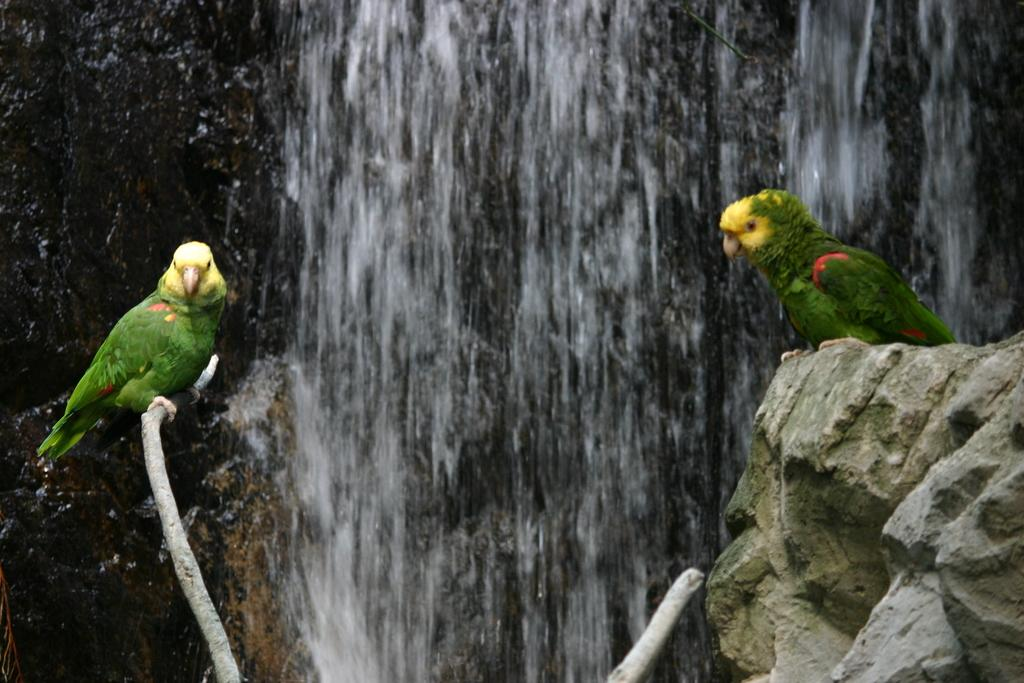How many birds are present in the image? There are two birds in the image. What else can be seen in the image besides the birds? There is a rock in the image. What is visible in the background of the image? There is a waterfall in the background of the image. What type of drug is the bird holding in its beak in the image? There is no drug present in the image; the birds are not holding anything in their beaks. 